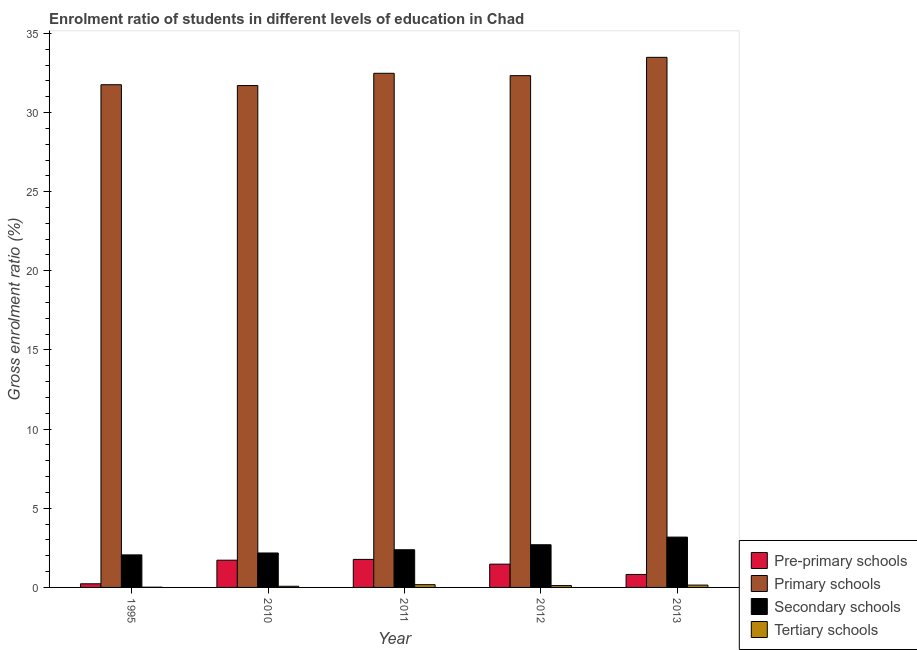How many different coloured bars are there?
Make the answer very short. 4. Are the number of bars on each tick of the X-axis equal?
Offer a terse response. Yes. How many bars are there on the 2nd tick from the left?
Make the answer very short. 4. How many bars are there on the 1st tick from the right?
Make the answer very short. 4. In how many cases, is the number of bars for a given year not equal to the number of legend labels?
Ensure brevity in your answer.  0. What is the gross enrolment ratio in pre-primary schools in 2012?
Offer a very short reply. 1.47. Across all years, what is the maximum gross enrolment ratio in tertiary schools?
Keep it short and to the point. 0.17. Across all years, what is the minimum gross enrolment ratio in tertiary schools?
Offer a very short reply. 0.01. What is the total gross enrolment ratio in tertiary schools in the graph?
Ensure brevity in your answer.  0.53. What is the difference between the gross enrolment ratio in secondary schools in 2012 and that in 2013?
Offer a very short reply. -0.48. What is the difference between the gross enrolment ratio in primary schools in 2013 and the gross enrolment ratio in pre-primary schools in 2011?
Offer a terse response. 1.01. What is the average gross enrolment ratio in secondary schools per year?
Your answer should be compact. 2.5. In the year 2010, what is the difference between the gross enrolment ratio in secondary schools and gross enrolment ratio in tertiary schools?
Keep it short and to the point. 0. In how many years, is the gross enrolment ratio in pre-primary schools greater than 7 %?
Keep it short and to the point. 0. What is the ratio of the gross enrolment ratio in secondary schools in 1995 to that in 2012?
Your response must be concise. 0.76. Is the gross enrolment ratio in tertiary schools in 1995 less than that in 2010?
Your response must be concise. Yes. What is the difference between the highest and the second highest gross enrolment ratio in pre-primary schools?
Your answer should be compact. 0.05. What is the difference between the highest and the lowest gross enrolment ratio in tertiary schools?
Ensure brevity in your answer.  0.16. Is the sum of the gross enrolment ratio in tertiary schools in 1995 and 2012 greater than the maximum gross enrolment ratio in secondary schools across all years?
Make the answer very short. No. What does the 4th bar from the left in 2013 represents?
Your answer should be compact. Tertiary schools. What does the 2nd bar from the right in 2011 represents?
Provide a succinct answer. Secondary schools. Is it the case that in every year, the sum of the gross enrolment ratio in pre-primary schools and gross enrolment ratio in primary schools is greater than the gross enrolment ratio in secondary schools?
Your answer should be compact. Yes. How many bars are there?
Offer a very short reply. 20. How many years are there in the graph?
Ensure brevity in your answer.  5. Where does the legend appear in the graph?
Provide a succinct answer. Bottom right. What is the title of the graph?
Your answer should be very brief. Enrolment ratio of students in different levels of education in Chad. Does "Interest Payments" appear as one of the legend labels in the graph?
Give a very brief answer. No. What is the Gross enrolment ratio (%) of Pre-primary schools in 1995?
Give a very brief answer. 0.23. What is the Gross enrolment ratio (%) of Primary schools in 1995?
Your answer should be compact. 31.75. What is the Gross enrolment ratio (%) in Secondary schools in 1995?
Your answer should be very brief. 2.06. What is the Gross enrolment ratio (%) of Tertiary schools in 1995?
Make the answer very short. 0.01. What is the Gross enrolment ratio (%) of Pre-primary schools in 2010?
Your response must be concise. 1.72. What is the Gross enrolment ratio (%) in Primary schools in 2010?
Give a very brief answer. 31.7. What is the Gross enrolment ratio (%) of Secondary schools in 2010?
Ensure brevity in your answer.  2.18. What is the Gross enrolment ratio (%) of Tertiary schools in 2010?
Provide a short and direct response. 0.07. What is the Gross enrolment ratio (%) of Pre-primary schools in 2011?
Give a very brief answer. 1.77. What is the Gross enrolment ratio (%) in Primary schools in 2011?
Ensure brevity in your answer.  32.48. What is the Gross enrolment ratio (%) of Secondary schools in 2011?
Offer a terse response. 2.38. What is the Gross enrolment ratio (%) in Tertiary schools in 2011?
Ensure brevity in your answer.  0.17. What is the Gross enrolment ratio (%) in Pre-primary schools in 2012?
Provide a short and direct response. 1.47. What is the Gross enrolment ratio (%) of Primary schools in 2012?
Make the answer very short. 32.33. What is the Gross enrolment ratio (%) of Secondary schools in 2012?
Make the answer very short. 2.7. What is the Gross enrolment ratio (%) of Tertiary schools in 2012?
Offer a terse response. 0.12. What is the Gross enrolment ratio (%) in Pre-primary schools in 2013?
Make the answer very short. 0.82. What is the Gross enrolment ratio (%) in Primary schools in 2013?
Make the answer very short. 33.49. What is the Gross enrolment ratio (%) in Secondary schools in 2013?
Offer a very short reply. 3.18. What is the Gross enrolment ratio (%) in Tertiary schools in 2013?
Provide a short and direct response. 0.15. Across all years, what is the maximum Gross enrolment ratio (%) in Pre-primary schools?
Ensure brevity in your answer.  1.77. Across all years, what is the maximum Gross enrolment ratio (%) of Primary schools?
Your response must be concise. 33.49. Across all years, what is the maximum Gross enrolment ratio (%) in Secondary schools?
Give a very brief answer. 3.18. Across all years, what is the maximum Gross enrolment ratio (%) in Tertiary schools?
Your answer should be compact. 0.17. Across all years, what is the minimum Gross enrolment ratio (%) of Pre-primary schools?
Ensure brevity in your answer.  0.23. Across all years, what is the minimum Gross enrolment ratio (%) in Primary schools?
Your answer should be very brief. 31.7. Across all years, what is the minimum Gross enrolment ratio (%) in Secondary schools?
Ensure brevity in your answer.  2.06. Across all years, what is the minimum Gross enrolment ratio (%) in Tertiary schools?
Your answer should be very brief. 0.01. What is the total Gross enrolment ratio (%) in Pre-primary schools in the graph?
Your answer should be compact. 6.01. What is the total Gross enrolment ratio (%) in Primary schools in the graph?
Offer a terse response. 161.75. What is the total Gross enrolment ratio (%) in Secondary schools in the graph?
Provide a succinct answer. 12.49. What is the total Gross enrolment ratio (%) of Tertiary schools in the graph?
Your answer should be compact. 0.53. What is the difference between the Gross enrolment ratio (%) in Pre-primary schools in 1995 and that in 2010?
Your response must be concise. -1.49. What is the difference between the Gross enrolment ratio (%) in Primary schools in 1995 and that in 2010?
Your response must be concise. 0.05. What is the difference between the Gross enrolment ratio (%) of Secondary schools in 1995 and that in 2010?
Provide a short and direct response. -0.12. What is the difference between the Gross enrolment ratio (%) in Tertiary schools in 1995 and that in 2010?
Offer a terse response. -0.06. What is the difference between the Gross enrolment ratio (%) in Pre-primary schools in 1995 and that in 2011?
Make the answer very short. -1.54. What is the difference between the Gross enrolment ratio (%) of Primary schools in 1995 and that in 2011?
Provide a succinct answer. -0.72. What is the difference between the Gross enrolment ratio (%) in Secondary schools in 1995 and that in 2011?
Your answer should be very brief. -0.32. What is the difference between the Gross enrolment ratio (%) in Tertiary schools in 1995 and that in 2011?
Provide a succinct answer. -0.16. What is the difference between the Gross enrolment ratio (%) of Pre-primary schools in 1995 and that in 2012?
Your answer should be compact. -1.24. What is the difference between the Gross enrolment ratio (%) in Primary schools in 1995 and that in 2012?
Ensure brevity in your answer.  -0.57. What is the difference between the Gross enrolment ratio (%) of Secondary schools in 1995 and that in 2012?
Provide a succinct answer. -0.64. What is the difference between the Gross enrolment ratio (%) in Tertiary schools in 1995 and that in 2012?
Your answer should be very brief. -0.1. What is the difference between the Gross enrolment ratio (%) in Pre-primary schools in 1995 and that in 2013?
Ensure brevity in your answer.  -0.59. What is the difference between the Gross enrolment ratio (%) in Primary schools in 1995 and that in 2013?
Make the answer very short. -1.73. What is the difference between the Gross enrolment ratio (%) in Secondary schools in 1995 and that in 2013?
Offer a very short reply. -1.12. What is the difference between the Gross enrolment ratio (%) in Tertiary schools in 1995 and that in 2013?
Your answer should be compact. -0.13. What is the difference between the Gross enrolment ratio (%) of Pre-primary schools in 2010 and that in 2011?
Your answer should be very brief. -0.05. What is the difference between the Gross enrolment ratio (%) of Primary schools in 2010 and that in 2011?
Provide a succinct answer. -0.77. What is the difference between the Gross enrolment ratio (%) of Secondary schools in 2010 and that in 2011?
Your answer should be very brief. -0.2. What is the difference between the Gross enrolment ratio (%) of Tertiary schools in 2010 and that in 2011?
Offer a terse response. -0.1. What is the difference between the Gross enrolment ratio (%) in Pre-primary schools in 2010 and that in 2012?
Offer a terse response. 0.25. What is the difference between the Gross enrolment ratio (%) of Primary schools in 2010 and that in 2012?
Offer a very short reply. -0.63. What is the difference between the Gross enrolment ratio (%) in Secondary schools in 2010 and that in 2012?
Keep it short and to the point. -0.52. What is the difference between the Gross enrolment ratio (%) of Tertiary schools in 2010 and that in 2012?
Your response must be concise. -0.04. What is the difference between the Gross enrolment ratio (%) in Pre-primary schools in 2010 and that in 2013?
Offer a terse response. 0.9. What is the difference between the Gross enrolment ratio (%) in Primary schools in 2010 and that in 2013?
Provide a succinct answer. -1.78. What is the difference between the Gross enrolment ratio (%) in Secondary schools in 2010 and that in 2013?
Keep it short and to the point. -1. What is the difference between the Gross enrolment ratio (%) in Tertiary schools in 2010 and that in 2013?
Give a very brief answer. -0.07. What is the difference between the Gross enrolment ratio (%) of Pre-primary schools in 2011 and that in 2012?
Offer a terse response. 0.3. What is the difference between the Gross enrolment ratio (%) in Primary schools in 2011 and that in 2012?
Make the answer very short. 0.15. What is the difference between the Gross enrolment ratio (%) in Secondary schools in 2011 and that in 2012?
Your answer should be very brief. -0.32. What is the difference between the Gross enrolment ratio (%) in Tertiary schools in 2011 and that in 2012?
Make the answer very short. 0.06. What is the difference between the Gross enrolment ratio (%) of Pre-primary schools in 2011 and that in 2013?
Your response must be concise. 0.95. What is the difference between the Gross enrolment ratio (%) of Primary schools in 2011 and that in 2013?
Provide a short and direct response. -1.01. What is the difference between the Gross enrolment ratio (%) of Secondary schools in 2011 and that in 2013?
Your answer should be very brief. -0.8. What is the difference between the Gross enrolment ratio (%) of Tertiary schools in 2011 and that in 2013?
Ensure brevity in your answer.  0.03. What is the difference between the Gross enrolment ratio (%) in Pre-primary schools in 2012 and that in 2013?
Make the answer very short. 0.65. What is the difference between the Gross enrolment ratio (%) in Primary schools in 2012 and that in 2013?
Your answer should be very brief. -1.16. What is the difference between the Gross enrolment ratio (%) in Secondary schools in 2012 and that in 2013?
Provide a short and direct response. -0.48. What is the difference between the Gross enrolment ratio (%) in Tertiary schools in 2012 and that in 2013?
Your answer should be compact. -0.03. What is the difference between the Gross enrolment ratio (%) of Pre-primary schools in 1995 and the Gross enrolment ratio (%) of Primary schools in 2010?
Provide a succinct answer. -31.47. What is the difference between the Gross enrolment ratio (%) of Pre-primary schools in 1995 and the Gross enrolment ratio (%) of Secondary schools in 2010?
Make the answer very short. -1.95. What is the difference between the Gross enrolment ratio (%) of Pre-primary schools in 1995 and the Gross enrolment ratio (%) of Tertiary schools in 2010?
Offer a very short reply. 0.16. What is the difference between the Gross enrolment ratio (%) of Primary schools in 1995 and the Gross enrolment ratio (%) of Secondary schools in 2010?
Provide a succinct answer. 29.58. What is the difference between the Gross enrolment ratio (%) in Primary schools in 1995 and the Gross enrolment ratio (%) in Tertiary schools in 2010?
Offer a terse response. 31.68. What is the difference between the Gross enrolment ratio (%) of Secondary schools in 1995 and the Gross enrolment ratio (%) of Tertiary schools in 2010?
Provide a succinct answer. 1.98. What is the difference between the Gross enrolment ratio (%) of Pre-primary schools in 1995 and the Gross enrolment ratio (%) of Primary schools in 2011?
Your answer should be very brief. -32.25. What is the difference between the Gross enrolment ratio (%) in Pre-primary schools in 1995 and the Gross enrolment ratio (%) in Secondary schools in 2011?
Offer a terse response. -2.15. What is the difference between the Gross enrolment ratio (%) in Pre-primary schools in 1995 and the Gross enrolment ratio (%) in Tertiary schools in 2011?
Offer a very short reply. 0.06. What is the difference between the Gross enrolment ratio (%) of Primary schools in 1995 and the Gross enrolment ratio (%) of Secondary schools in 2011?
Keep it short and to the point. 29.37. What is the difference between the Gross enrolment ratio (%) in Primary schools in 1995 and the Gross enrolment ratio (%) in Tertiary schools in 2011?
Provide a succinct answer. 31.58. What is the difference between the Gross enrolment ratio (%) in Secondary schools in 1995 and the Gross enrolment ratio (%) in Tertiary schools in 2011?
Provide a short and direct response. 1.88. What is the difference between the Gross enrolment ratio (%) of Pre-primary schools in 1995 and the Gross enrolment ratio (%) of Primary schools in 2012?
Offer a very short reply. -32.1. What is the difference between the Gross enrolment ratio (%) of Pre-primary schools in 1995 and the Gross enrolment ratio (%) of Secondary schools in 2012?
Your answer should be compact. -2.47. What is the difference between the Gross enrolment ratio (%) of Pre-primary schools in 1995 and the Gross enrolment ratio (%) of Tertiary schools in 2012?
Ensure brevity in your answer.  0.11. What is the difference between the Gross enrolment ratio (%) of Primary schools in 1995 and the Gross enrolment ratio (%) of Secondary schools in 2012?
Your response must be concise. 29.06. What is the difference between the Gross enrolment ratio (%) in Primary schools in 1995 and the Gross enrolment ratio (%) in Tertiary schools in 2012?
Your answer should be compact. 31.64. What is the difference between the Gross enrolment ratio (%) of Secondary schools in 1995 and the Gross enrolment ratio (%) of Tertiary schools in 2012?
Ensure brevity in your answer.  1.94. What is the difference between the Gross enrolment ratio (%) in Pre-primary schools in 1995 and the Gross enrolment ratio (%) in Primary schools in 2013?
Make the answer very short. -33.26. What is the difference between the Gross enrolment ratio (%) in Pre-primary schools in 1995 and the Gross enrolment ratio (%) in Secondary schools in 2013?
Provide a short and direct response. -2.95. What is the difference between the Gross enrolment ratio (%) of Pre-primary schools in 1995 and the Gross enrolment ratio (%) of Tertiary schools in 2013?
Your answer should be compact. 0.08. What is the difference between the Gross enrolment ratio (%) in Primary schools in 1995 and the Gross enrolment ratio (%) in Secondary schools in 2013?
Your response must be concise. 28.58. What is the difference between the Gross enrolment ratio (%) of Primary schools in 1995 and the Gross enrolment ratio (%) of Tertiary schools in 2013?
Your answer should be compact. 31.61. What is the difference between the Gross enrolment ratio (%) in Secondary schools in 1995 and the Gross enrolment ratio (%) in Tertiary schools in 2013?
Ensure brevity in your answer.  1.91. What is the difference between the Gross enrolment ratio (%) in Pre-primary schools in 2010 and the Gross enrolment ratio (%) in Primary schools in 2011?
Offer a very short reply. -30.76. What is the difference between the Gross enrolment ratio (%) in Pre-primary schools in 2010 and the Gross enrolment ratio (%) in Secondary schools in 2011?
Make the answer very short. -0.66. What is the difference between the Gross enrolment ratio (%) in Pre-primary schools in 2010 and the Gross enrolment ratio (%) in Tertiary schools in 2011?
Provide a short and direct response. 1.55. What is the difference between the Gross enrolment ratio (%) of Primary schools in 2010 and the Gross enrolment ratio (%) of Secondary schools in 2011?
Your answer should be compact. 29.32. What is the difference between the Gross enrolment ratio (%) in Primary schools in 2010 and the Gross enrolment ratio (%) in Tertiary schools in 2011?
Provide a succinct answer. 31.53. What is the difference between the Gross enrolment ratio (%) of Secondary schools in 2010 and the Gross enrolment ratio (%) of Tertiary schools in 2011?
Offer a terse response. 2. What is the difference between the Gross enrolment ratio (%) in Pre-primary schools in 2010 and the Gross enrolment ratio (%) in Primary schools in 2012?
Offer a very short reply. -30.61. What is the difference between the Gross enrolment ratio (%) in Pre-primary schools in 2010 and the Gross enrolment ratio (%) in Secondary schools in 2012?
Keep it short and to the point. -0.98. What is the difference between the Gross enrolment ratio (%) of Pre-primary schools in 2010 and the Gross enrolment ratio (%) of Tertiary schools in 2012?
Your answer should be very brief. 1.6. What is the difference between the Gross enrolment ratio (%) of Primary schools in 2010 and the Gross enrolment ratio (%) of Secondary schools in 2012?
Provide a succinct answer. 29.01. What is the difference between the Gross enrolment ratio (%) of Primary schools in 2010 and the Gross enrolment ratio (%) of Tertiary schools in 2012?
Your answer should be very brief. 31.59. What is the difference between the Gross enrolment ratio (%) in Secondary schools in 2010 and the Gross enrolment ratio (%) in Tertiary schools in 2012?
Make the answer very short. 2.06. What is the difference between the Gross enrolment ratio (%) of Pre-primary schools in 2010 and the Gross enrolment ratio (%) of Primary schools in 2013?
Make the answer very short. -31.77. What is the difference between the Gross enrolment ratio (%) of Pre-primary schools in 2010 and the Gross enrolment ratio (%) of Secondary schools in 2013?
Your answer should be very brief. -1.46. What is the difference between the Gross enrolment ratio (%) in Pre-primary schools in 2010 and the Gross enrolment ratio (%) in Tertiary schools in 2013?
Your answer should be compact. 1.57. What is the difference between the Gross enrolment ratio (%) of Primary schools in 2010 and the Gross enrolment ratio (%) of Secondary schools in 2013?
Your response must be concise. 28.52. What is the difference between the Gross enrolment ratio (%) of Primary schools in 2010 and the Gross enrolment ratio (%) of Tertiary schools in 2013?
Make the answer very short. 31.55. What is the difference between the Gross enrolment ratio (%) in Secondary schools in 2010 and the Gross enrolment ratio (%) in Tertiary schools in 2013?
Your answer should be very brief. 2.03. What is the difference between the Gross enrolment ratio (%) in Pre-primary schools in 2011 and the Gross enrolment ratio (%) in Primary schools in 2012?
Ensure brevity in your answer.  -30.56. What is the difference between the Gross enrolment ratio (%) in Pre-primary schools in 2011 and the Gross enrolment ratio (%) in Secondary schools in 2012?
Your response must be concise. -0.93. What is the difference between the Gross enrolment ratio (%) in Pre-primary schools in 2011 and the Gross enrolment ratio (%) in Tertiary schools in 2012?
Keep it short and to the point. 1.65. What is the difference between the Gross enrolment ratio (%) of Primary schools in 2011 and the Gross enrolment ratio (%) of Secondary schools in 2012?
Offer a terse response. 29.78. What is the difference between the Gross enrolment ratio (%) of Primary schools in 2011 and the Gross enrolment ratio (%) of Tertiary schools in 2012?
Offer a terse response. 32.36. What is the difference between the Gross enrolment ratio (%) in Secondary schools in 2011 and the Gross enrolment ratio (%) in Tertiary schools in 2012?
Keep it short and to the point. 2.26. What is the difference between the Gross enrolment ratio (%) in Pre-primary schools in 2011 and the Gross enrolment ratio (%) in Primary schools in 2013?
Your response must be concise. -31.72. What is the difference between the Gross enrolment ratio (%) in Pre-primary schools in 2011 and the Gross enrolment ratio (%) in Secondary schools in 2013?
Offer a very short reply. -1.41. What is the difference between the Gross enrolment ratio (%) of Pre-primary schools in 2011 and the Gross enrolment ratio (%) of Tertiary schools in 2013?
Offer a terse response. 1.62. What is the difference between the Gross enrolment ratio (%) of Primary schools in 2011 and the Gross enrolment ratio (%) of Secondary schools in 2013?
Ensure brevity in your answer.  29.3. What is the difference between the Gross enrolment ratio (%) of Primary schools in 2011 and the Gross enrolment ratio (%) of Tertiary schools in 2013?
Provide a short and direct response. 32.33. What is the difference between the Gross enrolment ratio (%) of Secondary schools in 2011 and the Gross enrolment ratio (%) of Tertiary schools in 2013?
Your response must be concise. 2.23. What is the difference between the Gross enrolment ratio (%) of Pre-primary schools in 2012 and the Gross enrolment ratio (%) of Primary schools in 2013?
Your answer should be compact. -32.02. What is the difference between the Gross enrolment ratio (%) in Pre-primary schools in 2012 and the Gross enrolment ratio (%) in Secondary schools in 2013?
Your response must be concise. -1.71. What is the difference between the Gross enrolment ratio (%) of Pre-primary schools in 2012 and the Gross enrolment ratio (%) of Tertiary schools in 2013?
Your answer should be very brief. 1.32. What is the difference between the Gross enrolment ratio (%) in Primary schools in 2012 and the Gross enrolment ratio (%) in Secondary schools in 2013?
Ensure brevity in your answer.  29.15. What is the difference between the Gross enrolment ratio (%) of Primary schools in 2012 and the Gross enrolment ratio (%) of Tertiary schools in 2013?
Your response must be concise. 32.18. What is the difference between the Gross enrolment ratio (%) in Secondary schools in 2012 and the Gross enrolment ratio (%) in Tertiary schools in 2013?
Ensure brevity in your answer.  2.55. What is the average Gross enrolment ratio (%) of Pre-primary schools per year?
Ensure brevity in your answer.  1.2. What is the average Gross enrolment ratio (%) in Primary schools per year?
Give a very brief answer. 32.35. What is the average Gross enrolment ratio (%) of Secondary schools per year?
Give a very brief answer. 2.5. What is the average Gross enrolment ratio (%) in Tertiary schools per year?
Provide a short and direct response. 0.11. In the year 1995, what is the difference between the Gross enrolment ratio (%) of Pre-primary schools and Gross enrolment ratio (%) of Primary schools?
Your answer should be compact. -31.52. In the year 1995, what is the difference between the Gross enrolment ratio (%) in Pre-primary schools and Gross enrolment ratio (%) in Secondary schools?
Offer a terse response. -1.83. In the year 1995, what is the difference between the Gross enrolment ratio (%) of Pre-primary schools and Gross enrolment ratio (%) of Tertiary schools?
Your response must be concise. 0.22. In the year 1995, what is the difference between the Gross enrolment ratio (%) of Primary schools and Gross enrolment ratio (%) of Secondary schools?
Provide a succinct answer. 29.7. In the year 1995, what is the difference between the Gross enrolment ratio (%) of Primary schools and Gross enrolment ratio (%) of Tertiary schools?
Offer a very short reply. 31.74. In the year 1995, what is the difference between the Gross enrolment ratio (%) of Secondary schools and Gross enrolment ratio (%) of Tertiary schools?
Your answer should be very brief. 2.04. In the year 2010, what is the difference between the Gross enrolment ratio (%) in Pre-primary schools and Gross enrolment ratio (%) in Primary schools?
Provide a succinct answer. -29.98. In the year 2010, what is the difference between the Gross enrolment ratio (%) of Pre-primary schools and Gross enrolment ratio (%) of Secondary schools?
Offer a terse response. -0.46. In the year 2010, what is the difference between the Gross enrolment ratio (%) of Pre-primary schools and Gross enrolment ratio (%) of Tertiary schools?
Offer a terse response. 1.65. In the year 2010, what is the difference between the Gross enrolment ratio (%) in Primary schools and Gross enrolment ratio (%) in Secondary schools?
Offer a terse response. 29.53. In the year 2010, what is the difference between the Gross enrolment ratio (%) of Primary schools and Gross enrolment ratio (%) of Tertiary schools?
Give a very brief answer. 31.63. In the year 2010, what is the difference between the Gross enrolment ratio (%) in Secondary schools and Gross enrolment ratio (%) in Tertiary schools?
Ensure brevity in your answer.  2.1. In the year 2011, what is the difference between the Gross enrolment ratio (%) of Pre-primary schools and Gross enrolment ratio (%) of Primary schools?
Keep it short and to the point. -30.71. In the year 2011, what is the difference between the Gross enrolment ratio (%) of Pre-primary schools and Gross enrolment ratio (%) of Secondary schools?
Make the answer very short. -0.61. In the year 2011, what is the difference between the Gross enrolment ratio (%) in Pre-primary schools and Gross enrolment ratio (%) in Tertiary schools?
Provide a short and direct response. 1.6. In the year 2011, what is the difference between the Gross enrolment ratio (%) of Primary schools and Gross enrolment ratio (%) of Secondary schools?
Offer a terse response. 30.1. In the year 2011, what is the difference between the Gross enrolment ratio (%) in Primary schools and Gross enrolment ratio (%) in Tertiary schools?
Make the answer very short. 32.3. In the year 2011, what is the difference between the Gross enrolment ratio (%) in Secondary schools and Gross enrolment ratio (%) in Tertiary schools?
Give a very brief answer. 2.21. In the year 2012, what is the difference between the Gross enrolment ratio (%) of Pre-primary schools and Gross enrolment ratio (%) of Primary schools?
Keep it short and to the point. -30.86. In the year 2012, what is the difference between the Gross enrolment ratio (%) of Pre-primary schools and Gross enrolment ratio (%) of Secondary schools?
Make the answer very short. -1.23. In the year 2012, what is the difference between the Gross enrolment ratio (%) of Pre-primary schools and Gross enrolment ratio (%) of Tertiary schools?
Provide a succinct answer. 1.35. In the year 2012, what is the difference between the Gross enrolment ratio (%) of Primary schools and Gross enrolment ratio (%) of Secondary schools?
Your answer should be compact. 29.63. In the year 2012, what is the difference between the Gross enrolment ratio (%) of Primary schools and Gross enrolment ratio (%) of Tertiary schools?
Ensure brevity in your answer.  32.21. In the year 2012, what is the difference between the Gross enrolment ratio (%) of Secondary schools and Gross enrolment ratio (%) of Tertiary schools?
Keep it short and to the point. 2.58. In the year 2013, what is the difference between the Gross enrolment ratio (%) in Pre-primary schools and Gross enrolment ratio (%) in Primary schools?
Your response must be concise. -32.67. In the year 2013, what is the difference between the Gross enrolment ratio (%) in Pre-primary schools and Gross enrolment ratio (%) in Secondary schools?
Your answer should be compact. -2.36. In the year 2013, what is the difference between the Gross enrolment ratio (%) of Pre-primary schools and Gross enrolment ratio (%) of Tertiary schools?
Your answer should be compact. 0.67. In the year 2013, what is the difference between the Gross enrolment ratio (%) of Primary schools and Gross enrolment ratio (%) of Secondary schools?
Make the answer very short. 30.31. In the year 2013, what is the difference between the Gross enrolment ratio (%) of Primary schools and Gross enrolment ratio (%) of Tertiary schools?
Your answer should be very brief. 33.34. In the year 2013, what is the difference between the Gross enrolment ratio (%) in Secondary schools and Gross enrolment ratio (%) in Tertiary schools?
Give a very brief answer. 3.03. What is the ratio of the Gross enrolment ratio (%) of Pre-primary schools in 1995 to that in 2010?
Offer a terse response. 0.13. What is the ratio of the Gross enrolment ratio (%) in Secondary schools in 1995 to that in 2010?
Your answer should be very brief. 0.94. What is the ratio of the Gross enrolment ratio (%) in Tertiary schools in 1995 to that in 2010?
Your answer should be very brief. 0.2. What is the ratio of the Gross enrolment ratio (%) in Pre-primary schools in 1995 to that in 2011?
Your response must be concise. 0.13. What is the ratio of the Gross enrolment ratio (%) of Primary schools in 1995 to that in 2011?
Ensure brevity in your answer.  0.98. What is the ratio of the Gross enrolment ratio (%) of Secondary schools in 1995 to that in 2011?
Ensure brevity in your answer.  0.86. What is the ratio of the Gross enrolment ratio (%) in Tertiary schools in 1995 to that in 2011?
Offer a very short reply. 0.08. What is the ratio of the Gross enrolment ratio (%) of Pre-primary schools in 1995 to that in 2012?
Your answer should be very brief. 0.16. What is the ratio of the Gross enrolment ratio (%) of Primary schools in 1995 to that in 2012?
Provide a short and direct response. 0.98. What is the ratio of the Gross enrolment ratio (%) of Secondary schools in 1995 to that in 2012?
Provide a succinct answer. 0.76. What is the ratio of the Gross enrolment ratio (%) in Tertiary schools in 1995 to that in 2012?
Your response must be concise. 0.13. What is the ratio of the Gross enrolment ratio (%) of Pre-primary schools in 1995 to that in 2013?
Your answer should be compact. 0.28. What is the ratio of the Gross enrolment ratio (%) of Primary schools in 1995 to that in 2013?
Your answer should be compact. 0.95. What is the ratio of the Gross enrolment ratio (%) of Secondary schools in 1995 to that in 2013?
Make the answer very short. 0.65. What is the ratio of the Gross enrolment ratio (%) of Tertiary schools in 1995 to that in 2013?
Give a very brief answer. 0.1. What is the ratio of the Gross enrolment ratio (%) of Pre-primary schools in 2010 to that in 2011?
Your response must be concise. 0.97. What is the ratio of the Gross enrolment ratio (%) in Primary schools in 2010 to that in 2011?
Offer a very short reply. 0.98. What is the ratio of the Gross enrolment ratio (%) of Secondary schools in 2010 to that in 2011?
Offer a terse response. 0.91. What is the ratio of the Gross enrolment ratio (%) of Tertiary schools in 2010 to that in 2011?
Ensure brevity in your answer.  0.42. What is the ratio of the Gross enrolment ratio (%) of Pre-primary schools in 2010 to that in 2012?
Provide a short and direct response. 1.17. What is the ratio of the Gross enrolment ratio (%) in Primary schools in 2010 to that in 2012?
Provide a short and direct response. 0.98. What is the ratio of the Gross enrolment ratio (%) of Secondary schools in 2010 to that in 2012?
Provide a succinct answer. 0.81. What is the ratio of the Gross enrolment ratio (%) of Tertiary schools in 2010 to that in 2012?
Provide a short and direct response. 0.63. What is the ratio of the Gross enrolment ratio (%) of Pre-primary schools in 2010 to that in 2013?
Give a very brief answer. 2.1. What is the ratio of the Gross enrolment ratio (%) in Primary schools in 2010 to that in 2013?
Give a very brief answer. 0.95. What is the ratio of the Gross enrolment ratio (%) of Secondary schools in 2010 to that in 2013?
Keep it short and to the point. 0.68. What is the ratio of the Gross enrolment ratio (%) of Tertiary schools in 2010 to that in 2013?
Make the answer very short. 0.5. What is the ratio of the Gross enrolment ratio (%) in Pre-primary schools in 2011 to that in 2012?
Ensure brevity in your answer.  1.2. What is the ratio of the Gross enrolment ratio (%) of Primary schools in 2011 to that in 2012?
Provide a succinct answer. 1. What is the ratio of the Gross enrolment ratio (%) of Secondary schools in 2011 to that in 2012?
Give a very brief answer. 0.88. What is the ratio of the Gross enrolment ratio (%) of Tertiary schools in 2011 to that in 2012?
Provide a short and direct response. 1.5. What is the ratio of the Gross enrolment ratio (%) in Pre-primary schools in 2011 to that in 2013?
Make the answer very short. 2.16. What is the ratio of the Gross enrolment ratio (%) in Primary schools in 2011 to that in 2013?
Provide a succinct answer. 0.97. What is the ratio of the Gross enrolment ratio (%) of Secondary schools in 2011 to that in 2013?
Your answer should be very brief. 0.75. What is the ratio of the Gross enrolment ratio (%) of Tertiary schools in 2011 to that in 2013?
Provide a short and direct response. 1.18. What is the ratio of the Gross enrolment ratio (%) of Pre-primary schools in 2012 to that in 2013?
Your answer should be compact. 1.8. What is the ratio of the Gross enrolment ratio (%) of Primary schools in 2012 to that in 2013?
Your answer should be compact. 0.97. What is the ratio of the Gross enrolment ratio (%) of Secondary schools in 2012 to that in 2013?
Your answer should be compact. 0.85. What is the ratio of the Gross enrolment ratio (%) in Tertiary schools in 2012 to that in 2013?
Your response must be concise. 0.79. What is the difference between the highest and the second highest Gross enrolment ratio (%) in Pre-primary schools?
Give a very brief answer. 0.05. What is the difference between the highest and the second highest Gross enrolment ratio (%) in Primary schools?
Give a very brief answer. 1.01. What is the difference between the highest and the second highest Gross enrolment ratio (%) in Secondary schools?
Your answer should be compact. 0.48. What is the difference between the highest and the second highest Gross enrolment ratio (%) of Tertiary schools?
Keep it short and to the point. 0.03. What is the difference between the highest and the lowest Gross enrolment ratio (%) of Pre-primary schools?
Your response must be concise. 1.54. What is the difference between the highest and the lowest Gross enrolment ratio (%) of Primary schools?
Provide a succinct answer. 1.78. What is the difference between the highest and the lowest Gross enrolment ratio (%) in Secondary schools?
Keep it short and to the point. 1.12. What is the difference between the highest and the lowest Gross enrolment ratio (%) of Tertiary schools?
Offer a terse response. 0.16. 